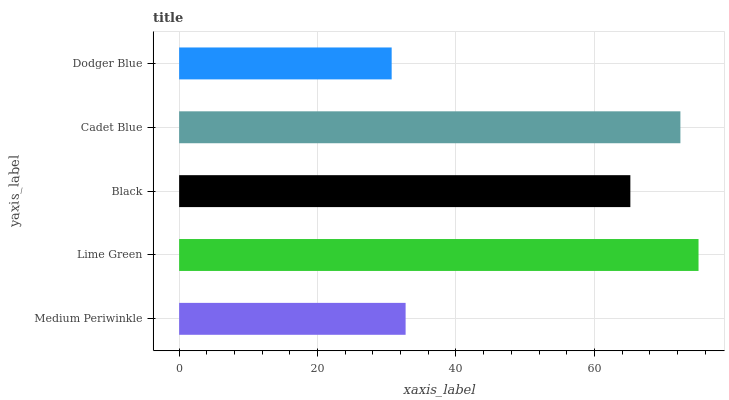Is Dodger Blue the minimum?
Answer yes or no. Yes. Is Lime Green the maximum?
Answer yes or no. Yes. Is Black the minimum?
Answer yes or no. No. Is Black the maximum?
Answer yes or no. No. Is Lime Green greater than Black?
Answer yes or no. Yes. Is Black less than Lime Green?
Answer yes or no. Yes. Is Black greater than Lime Green?
Answer yes or no. No. Is Lime Green less than Black?
Answer yes or no. No. Is Black the high median?
Answer yes or no. Yes. Is Black the low median?
Answer yes or no. Yes. Is Medium Periwinkle the high median?
Answer yes or no. No. Is Cadet Blue the low median?
Answer yes or no. No. 